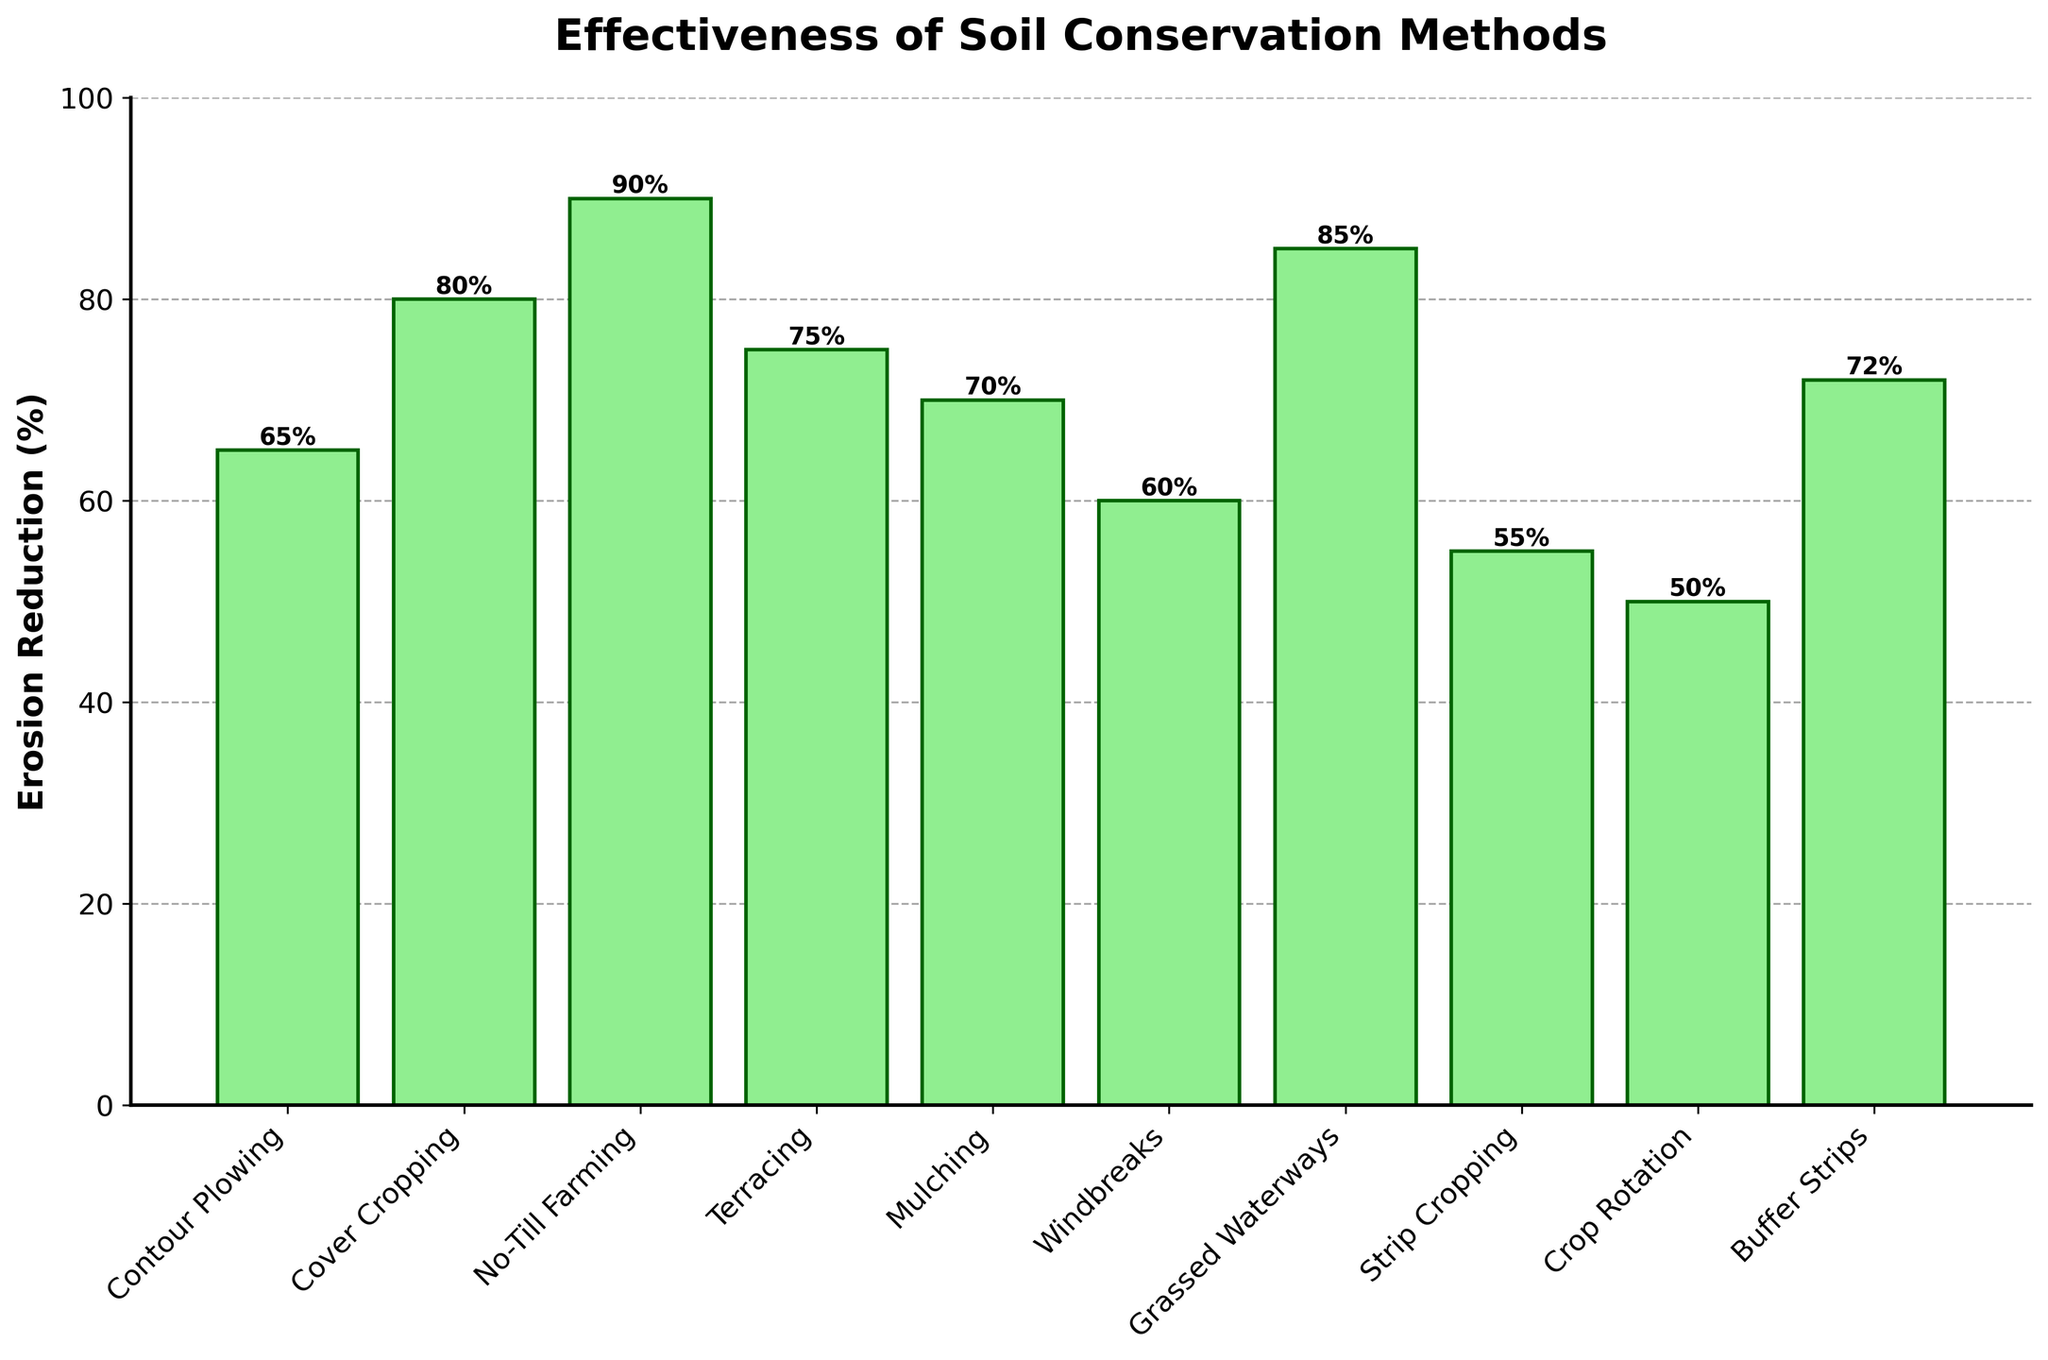Which soil conservation method is the most effective in reducing erosion rates? The figure shows the Erosion Reduction (%) for each method, with No-Till Farming having the highest bar at 90%.
Answer: No-Till Farming Which soil conservation method is the least effective in reducing erosion rates? The figure shows the Erosion Reduction (%) for each method, with Crop Rotation having the lowest bar at 50%.
Answer: Crop Rotation How much more effective is Cover Cropping compared to Strip Cropping? Cover Cropping reduces erosion by 80% while Strip Cropping reduces it by 55%. The difference is 80% - 55% = 25%.
Answer: 25% What is the average erosion reduction percentage for all soil conservation methods shown? Sum all the percentages and divide by the number of methods. (65 + 80 + 90 + 75 + 70 + 60 + 85 + 55 + 50 + 72) / 10 = 70.2%
Answer: 70.2% Which three methods reduce erosion by more than 80%? From the figure, No-Till Farming (90%), Grassed Waterways (85%), and Cover Cropping (80%) each have bars exceeding 80%.
Answer: No-Till Farming, Grassed Waterways, Cover Cropping By how much does Mulching reduce erosion compared to Windbreaks? Mulching reduces erosion by 70% and Windbreaks by 60%. The difference is 70% - 60% = 10%.
Answer: 10% Is Buffer Strips more effective than Contour Plowing? If so, by how much? Buffer Strips reduce erosion by 72% while Contour Plowing reduces it by 65%. The difference is 72% - 65% = 7%.
Answer: Yes, by 7% What is the combined erosion reduction percentage of the top three most effective methods? The top three methods are No-Till Farming (90%), Grassed Waterways (85%), and Cover Cropping (80%). Their combined reduction percentage is 90% + 85% + 80% = 255%.
Answer: 255% Which method has the smallest increase in effectiveness relative to the least effective method? Compare the difference in effectiveness between each method and the least effective method, Crop Rotation (50%):
- Contour Plowing: 65% - 50% = 15%
- Cover Cropping: 80% - 50% = 30%
- No-Till Farming: 90% - 50% = 40%
- Terracing: 75% - 50% = 25%
- Mulching: 70% - 50% = 20%
- Windbreaks: 60% - 50% = 10%
- Grassed Waterways: 85% - 50% = 35%
- Strip Cropping: 55% - 50% = 5%
- Buffer Strips: 72% - 50% = 22%
The smallest increase is for Strip Cropping at 5%.
Answer: Strip Cropping 